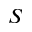<formula> <loc_0><loc_0><loc_500><loc_500>S</formula> 